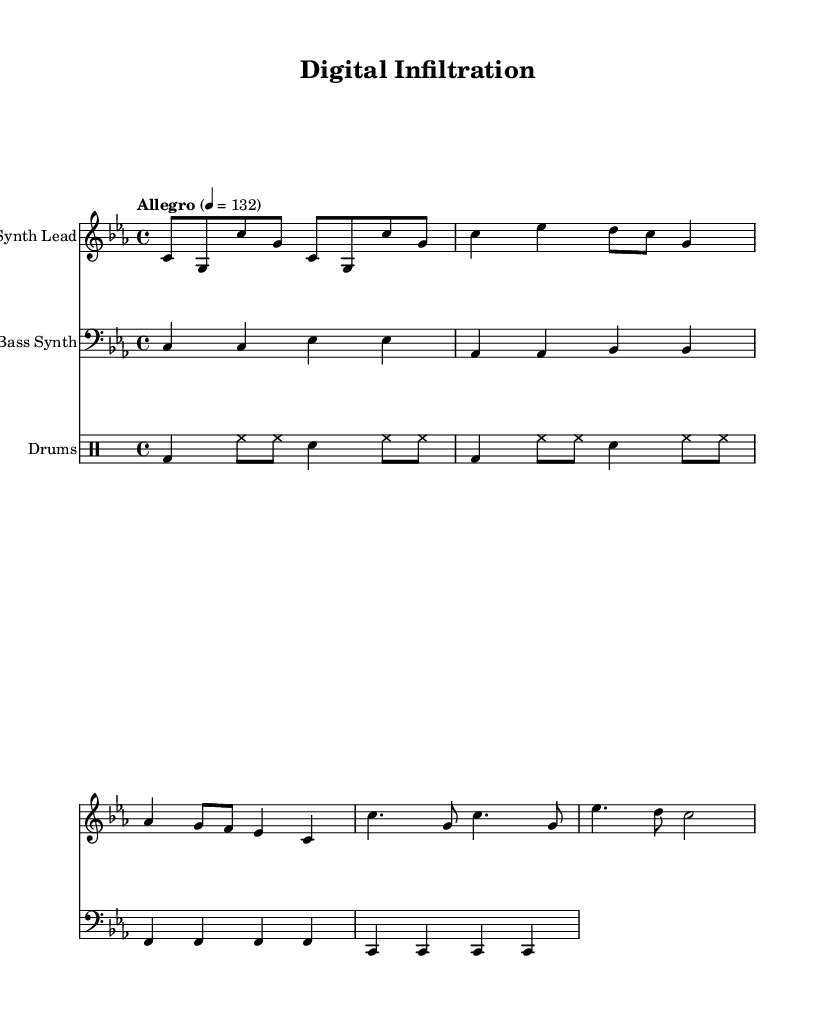What is the key signature of this music? The key signature is C minor, which includes three flats (B♭, E♭, A♭). This can be identified by looking at the key signature section located at the beginning of the score.
Answer: C minor What is the time signature of this music? The time signature is 4/4, meaning there are four beats in each measure and a quarter note receives one beat. This is indicated at the start of the score.
Answer: 4/4 What is the tempo marking for this piece? The tempo marking is "Allegro" with a specific tempo of quarter note equals 132 beats per minute. This is noted prominently at the start under the tempo indication.
Answer: Allegro How many measures are in the synth lead section? The synth lead section consists of eight measures. By counting the groupings of notes from the beginning to the end of this section, you can verify the total.
Answer: 8 Which instrument plays the bass part? The bass part is played by the Bass Synth, as indicated by the instrument name written on the staff.
Answer: Bass Synth What is the primary rhythmic pattern used in the drum section? The primary rhythmic pattern in the drum section features a kick drum (bd), hi-hat (hh), and snare drum (sn) in a repeating sequence. Analyzing the sequence reveals this recurring pattern.
Answer: Basic drum pattern What mood or atmosphere does the tempo and key signature create? The combination of a fast tempo (Allegro) and a minor key (C minor) typically evokes feelings of intensity and urgency, which is common in high-tech espionage thriller soundtracks. Evaluating the tempo and key signature together leads to this conclusion.
Answer: Intense atmosphere 